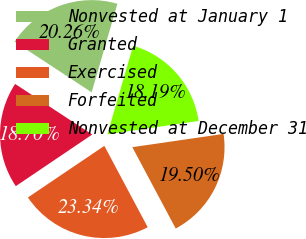Convert chart to OTSL. <chart><loc_0><loc_0><loc_500><loc_500><pie_chart><fcel>Nonvested at January 1<fcel>Granted<fcel>Exercised<fcel>Forfeited<fcel>Nonvested at December 31<nl><fcel>20.26%<fcel>18.7%<fcel>23.34%<fcel>19.5%<fcel>18.19%<nl></chart> 